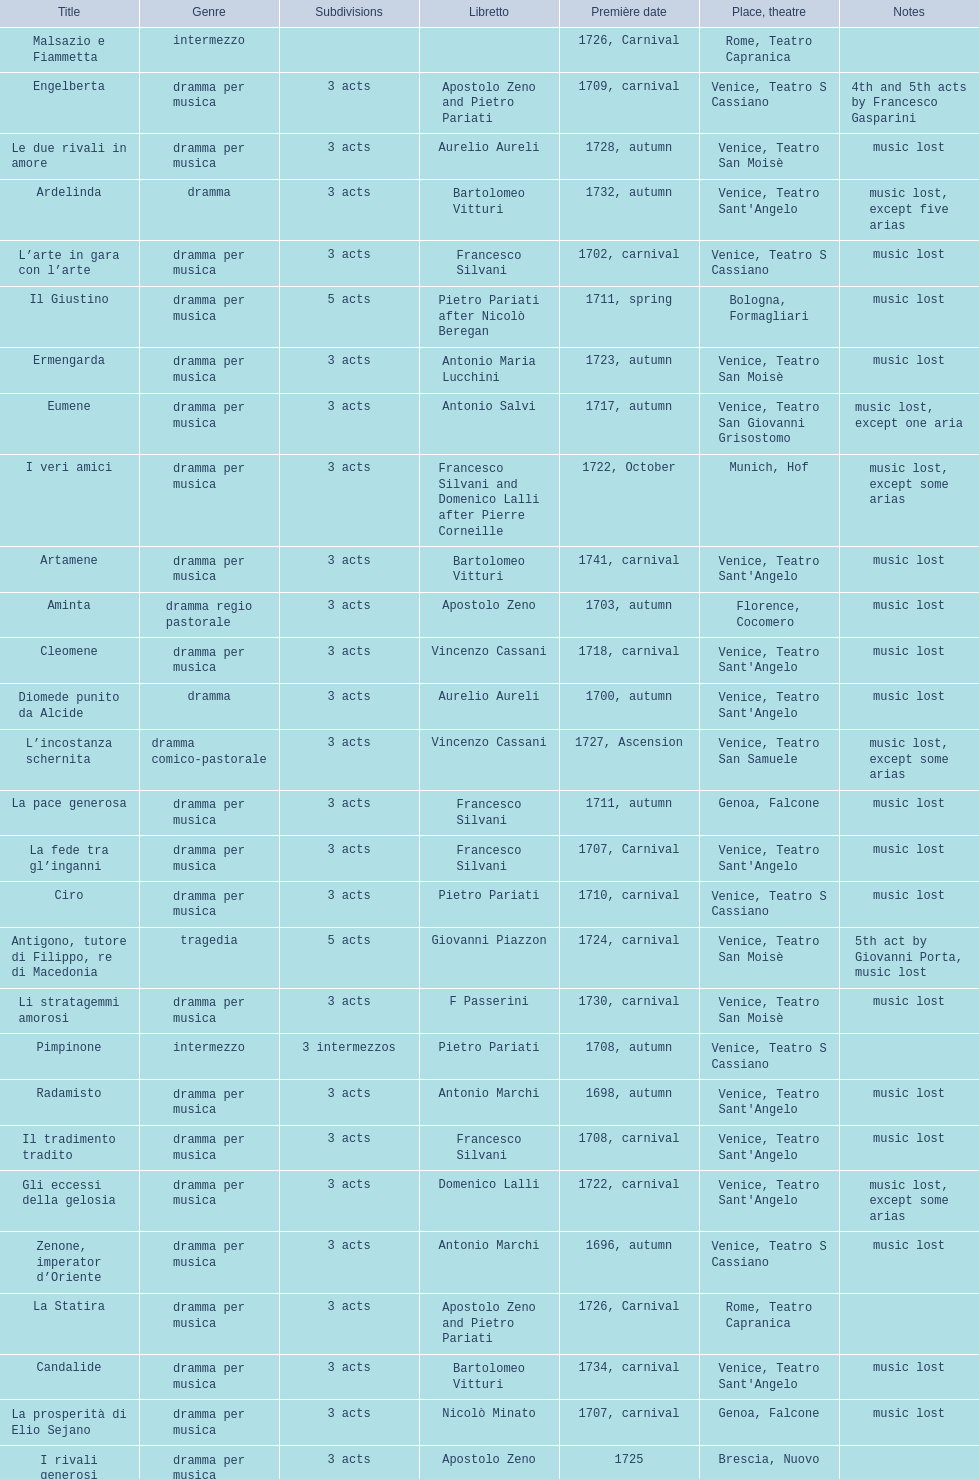What title made its debut right after candide? Artamene. 